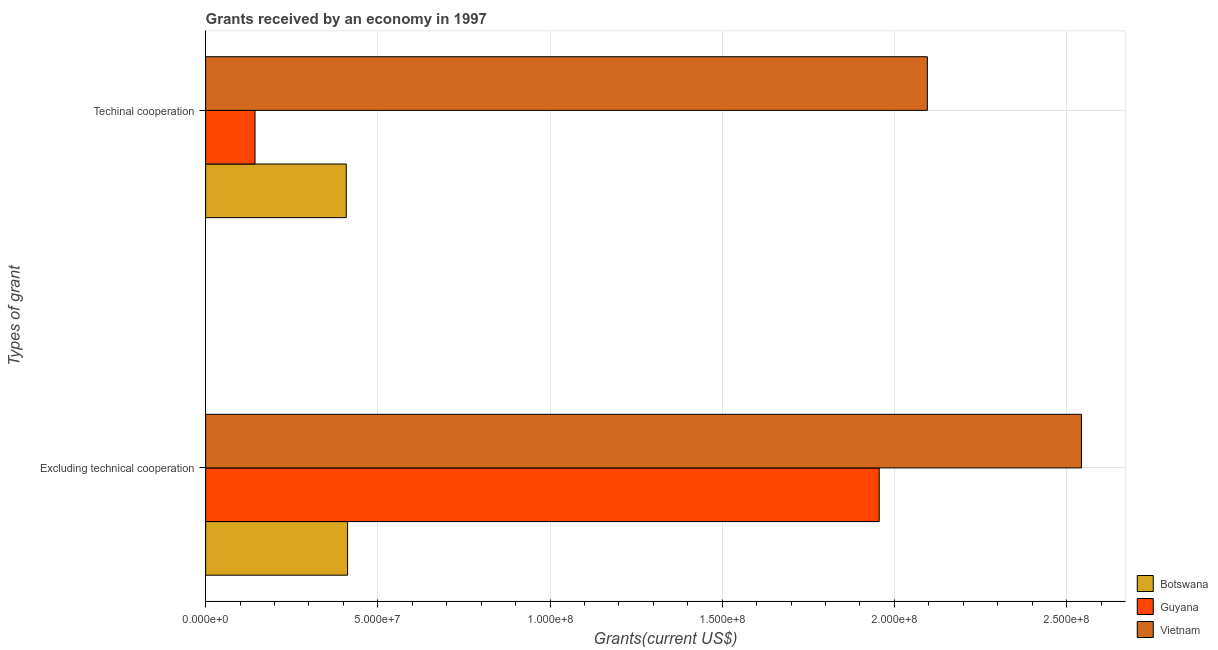How many different coloured bars are there?
Keep it short and to the point. 3. How many groups of bars are there?
Give a very brief answer. 2. Are the number of bars per tick equal to the number of legend labels?
Make the answer very short. Yes. What is the label of the 2nd group of bars from the top?
Provide a short and direct response. Excluding technical cooperation. What is the amount of grants received(excluding technical cooperation) in Botswana?
Your response must be concise. 4.12e+07. Across all countries, what is the maximum amount of grants received(including technical cooperation)?
Provide a short and direct response. 2.10e+08. Across all countries, what is the minimum amount of grants received(including technical cooperation)?
Keep it short and to the point. 1.43e+07. In which country was the amount of grants received(including technical cooperation) maximum?
Offer a very short reply. Vietnam. In which country was the amount of grants received(excluding technical cooperation) minimum?
Provide a short and direct response. Botswana. What is the total amount of grants received(including technical cooperation) in the graph?
Your answer should be very brief. 2.65e+08. What is the difference between the amount of grants received(including technical cooperation) in Vietnam and that in Guyana?
Your answer should be very brief. 1.95e+08. What is the difference between the amount of grants received(including technical cooperation) in Guyana and the amount of grants received(excluding technical cooperation) in Botswana?
Provide a short and direct response. -2.69e+07. What is the average amount of grants received(excluding technical cooperation) per country?
Offer a terse response. 1.64e+08. What is the difference between the amount of grants received(excluding technical cooperation) and amount of grants received(including technical cooperation) in Botswana?
Offer a very short reply. 3.80e+05. What is the ratio of the amount of grants received(excluding technical cooperation) in Guyana to that in Vietnam?
Make the answer very short. 0.77. What does the 3rd bar from the top in Techinal cooperation represents?
Offer a terse response. Botswana. What does the 2nd bar from the bottom in Techinal cooperation represents?
Keep it short and to the point. Guyana. How many bars are there?
Your answer should be very brief. 6. What is the difference between two consecutive major ticks on the X-axis?
Offer a terse response. 5.00e+07. Are the values on the major ticks of X-axis written in scientific E-notation?
Offer a terse response. Yes. Does the graph contain grids?
Offer a very short reply. Yes. Where does the legend appear in the graph?
Provide a short and direct response. Bottom right. How are the legend labels stacked?
Keep it short and to the point. Vertical. What is the title of the graph?
Make the answer very short. Grants received by an economy in 1997. What is the label or title of the X-axis?
Provide a short and direct response. Grants(current US$). What is the label or title of the Y-axis?
Offer a very short reply. Types of grant. What is the Grants(current US$) in Botswana in Excluding technical cooperation?
Ensure brevity in your answer.  4.12e+07. What is the Grants(current US$) of Guyana in Excluding technical cooperation?
Your response must be concise. 1.96e+08. What is the Grants(current US$) of Vietnam in Excluding technical cooperation?
Make the answer very short. 2.54e+08. What is the Grants(current US$) in Botswana in Techinal cooperation?
Keep it short and to the point. 4.08e+07. What is the Grants(current US$) in Guyana in Techinal cooperation?
Ensure brevity in your answer.  1.43e+07. What is the Grants(current US$) in Vietnam in Techinal cooperation?
Your response must be concise. 2.10e+08. Across all Types of grant, what is the maximum Grants(current US$) of Botswana?
Make the answer very short. 4.12e+07. Across all Types of grant, what is the maximum Grants(current US$) of Guyana?
Give a very brief answer. 1.96e+08. Across all Types of grant, what is the maximum Grants(current US$) in Vietnam?
Ensure brevity in your answer.  2.54e+08. Across all Types of grant, what is the minimum Grants(current US$) of Botswana?
Make the answer very short. 4.08e+07. Across all Types of grant, what is the minimum Grants(current US$) of Guyana?
Your answer should be very brief. 1.43e+07. Across all Types of grant, what is the minimum Grants(current US$) in Vietnam?
Your response must be concise. 2.10e+08. What is the total Grants(current US$) of Botswana in the graph?
Ensure brevity in your answer.  8.21e+07. What is the total Grants(current US$) of Guyana in the graph?
Provide a short and direct response. 2.10e+08. What is the total Grants(current US$) in Vietnam in the graph?
Make the answer very short. 4.64e+08. What is the difference between the Grants(current US$) in Botswana in Excluding technical cooperation and that in Techinal cooperation?
Ensure brevity in your answer.  3.80e+05. What is the difference between the Grants(current US$) in Guyana in Excluding technical cooperation and that in Techinal cooperation?
Offer a terse response. 1.81e+08. What is the difference between the Grants(current US$) in Vietnam in Excluding technical cooperation and that in Techinal cooperation?
Offer a terse response. 4.48e+07. What is the difference between the Grants(current US$) in Botswana in Excluding technical cooperation and the Grants(current US$) in Guyana in Techinal cooperation?
Your answer should be very brief. 2.69e+07. What is the difference between the Grants(current US$) of Botswana in Excluding technical cooperation and the Grants(current US$) of Vietnam in Techinal cooperation?
Your response must be concise. -1.68e+08. What is the difference between the Grants(current US$) in Guyana in Excluding technical cooperation and the Grants(current US$) in Vietnam in Techinal cooperation?
Give a very brief answer. -1.40e+07. What is the average Grants(current US$) of Botswana per Types of grant?
Keep it short and to the point. 4.10e+07. What is the average Grants(current US$) in Guyana per Types of grant?
Provide a short and direct response. 1.05e+08. What is the average Grants(current US$) of Vietnam per Types of grant?
Provide a succinct answer. 2.32e+08. What is the difference between the Grants(current US$) of Botswana and Grants(current US$) of Guyana in Excluding technical cooperation?
Your answer should be compact. -1.54e+08. What is the difference between the Grants(current US$) of Botswana and Grants(current US$) of Vietnam in Excluding technical cooperation?
Your response must be concise. -2.13e+08. What is the difference between the Grants(current US$) of Guyana and Grants(current US$) of Vietnam in Excluding technical cooperation?
Provide a short and direct response. -5.87e+07. What is the difference between the Grants(current US$) in Botswana and Grants(current US$) in Guyana in Techinal cooperation?
Your response must be concise. 2.65e+07. What is the difference between the Grants(current US$) in Botswana and Grants(current US$) in Vietnam in Techinal cooperation?
Ensure brevity in your answer.  -1.69e+08. What is the difference between the Grants(current US$) in Guyana and Grants(current US$) in Vietnam in Techinal cooperation?
Your answer should be compact. -1.95e+08. What is the ratio of the Grants(current US$) in Botswana in Excluding technical cooperation to that in Techinal cooperation?
Your answer should be very brief. 1.01. What is the ratio of the Grants(current US$) in Guyana in Excluding technical cooperation to that in Techinal cooperation?
Make the answer very short. 13.64. What is the ratio of the Grants(current US$) in Vietnam in Excluding technical cooperation to that in Techinal cooperation?
Provide a succinct answer. 1.21. What is the difference between the highest and the second highest Grants(current US$) of Guyana?
Your answer should be very brief. 1.81e+08. What is the difference between the highest and the second highest Grants(current US$) of Vietnam?
Provide a short and direct response. 4.48e+07. What is the difference between the highest and the lowest Grants(current US$) of Guyana?
Make the answer very short. 1.81e+08. What is the difference between the highest and the lowest Grants(current US$) of Vietnam?
Your answer should be very brief. 4.48e+07. 